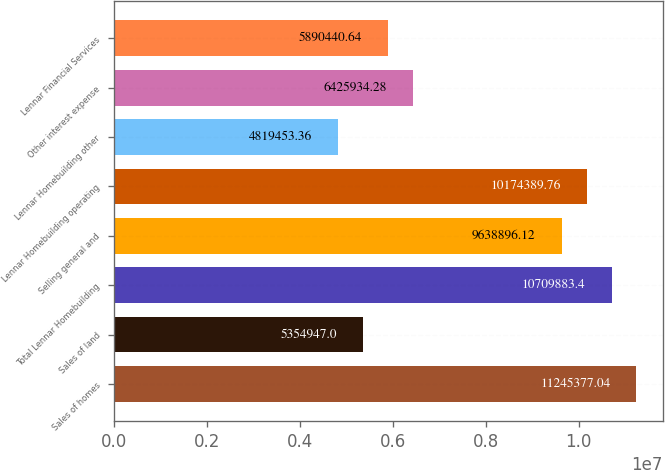Convert chart to OTSL. <chart><loc_0><loc_0><loc_500><loc_500><bar_chart><fcel>Sales of homes<fcel>Sales of land<fcel>Total Lennar Homebuilding<fcel>Selling general and<fcel>Lennar Homebuilding operating<fcel>Lennar Homebuilding other<fcel>Other interest expense<fcel>Lennar Financial Services<nl><fcel>1.12454e+07<fcel>5.35495e+06<fcel>1.07099e+07<fcel>9.6389e+06<fcel>1.01744e+07<fcel>4.81945e+06<fcel>6.42593e+06<fcel>5.89044e+06<nl></chart> 